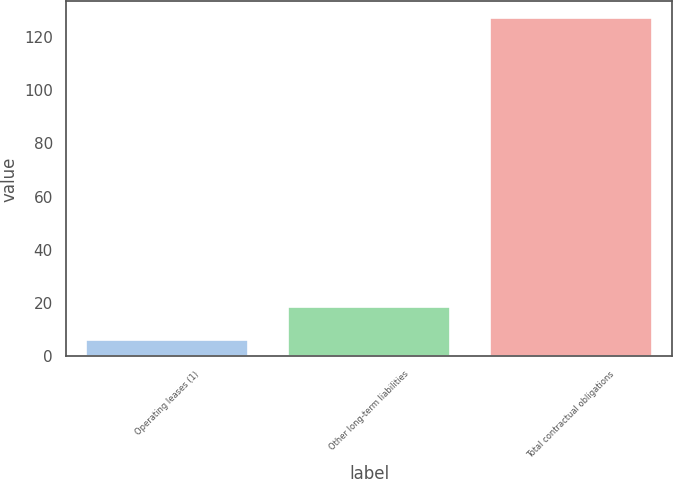Convert chart. <chart><loc_0><loc_0><loc_500><loc_500><bar_chart><fcel>Operating leases (1)<fcel>Other long-term liabilities<fcel>Total contractual obligations<nl><fcel>6.3<fcel>18.37<fcel>127<nl></chart> 